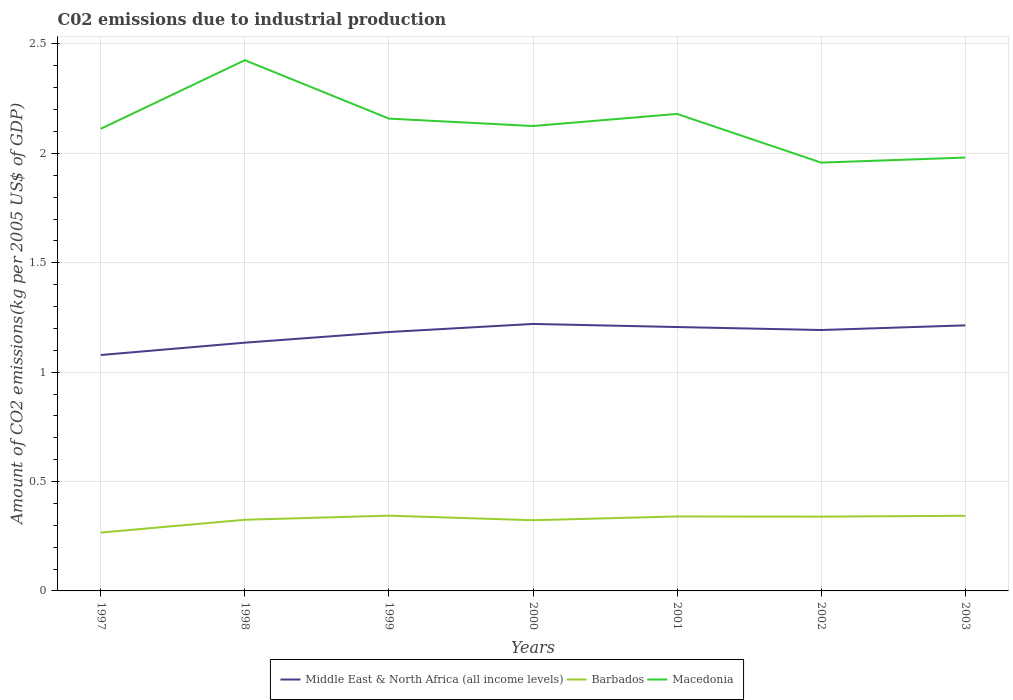How many different coloured lines are there?
Make the answer very short. 3. Does the line corresponding to Barbados intersect with the line corresponding to Macedonia?
Ensure brevity in your answer.  No. Across all years, what is the maximum amount of CO2 emitted due to industrial production in Macedonia?
Offer a terse response. 1.96. In which year was the amount of CO2 emitted due to industrial production in Middle East & North Africa (all income levels) maximum?
Give a very brief answer. 1997. What is the total amount of CO2 emitted due to industrial production in Barbados in the graph?
Make the answer very short. -0. What is the difference between the highest and the second highest amount of CO2 emitted due to industrial production in Middle East & North Africa (all income levels)?
Make the answer very short. 0.14. How many lines are there?
Give a very brief answer. 3. How many years are there in the graph?
Offer a very short reply. 7. Are the values on the major ticks of Y-axis written in scientific E-notation?
Ensure brevity in your answer.  No. Where does the legend appear in the graph?
Offer a very short reply. Bottom center. How many legend labels are there?
Make the answer very short. 3. How are the legend labels stacked?
Your response must be concise. Horizontal. What is the title of the graph?
Provide a short and direct response. C02 emissions due to industrial production. What is the label or title of the X-axis?
Make the answer very short. Years. What is the label or title of the Y-axis?
Make the answer very short. Amount of CO2 emissions(kg per 2005 US$ of GDP). What is the Amount of CO2 emissions(kg per 2005 US$ of GDP) in Middle East & North Africa (all income levels) in 1997?
Provide a succinct answer. 1.08. What is the Amount of CO2 emissions(kg per 2005 US$ of GDP) of Barbados in 1997?
Keep it short and to the point. 0.27. What is the Amount of CO2 emissions(kg per 2005 US$ of GDP) in Macedonia in 1997?
Make the answer very short. 2.11. What is the Amount of CO2 emissions(kg per 2005 US$ of GDP) in Middle East & North Africa (all income levels) in 1998?
Offer a terse response. 1.13. What is the Amount of CO2 emissions(kg per 2005 US$ of GDP) of Barbados in 1998?
Provide a short and direct response. 0.33. What is the Amount of CO2 emissions(kg per 2005 US$ of GDP) in Macedonia in 1998?
Provide a succinct answer. 2.43. What is the Amount of CO2 emissions(kg per 2005 US$ of GDP) of Middle East & North Africa (all income levels) in 1999?
Keep it short and to the point. 1.18. What is the Amount of CO2 emissions(kg per 2005 US$ of GDP) in Barbados in 1999?
Ensure brevity in your answer.  0.34. What is the Amount of CO2 emissions(kg per 2005 US$ of GDP) in Macedonia in 1999?
Your answer should be very brief. 2.16. What is the Amount of CO2 emissions(kg per 2005 US$ of GDP) in Middle East & North Africa (all income levels) in 2000?
Ensure brevity in your answer.  1.22. What is the Amount of CO2 emissions(kg per 2005 US$ of GDP) of Barbados in 2000?
Give a very brief answer. 0.32. What is the Amount of CO2 emissions(kg per 2005 US$ of GDP) of Macedonia in 2000?
Your answer should be compact. 2.13. What is the Amount of CO2 emissions(kg per 2005 US$ of GDP) of Middle East & North Africa (all income levels) in 2001?
Give a very brief answer. 1.21. What is the Amount of CO2 emissions(kg per 2005 US$ of GDP) in Barbados in 2001?
Give a very brief answer. 0.34. What is the Amount of CO2 emissions(kg per 2005 US$ of GDP) of Macedonia in 2001?
Your answer should be compact. 2.18. What is the Amount of CO2 emissions(kg per 2005 US$ of GDP) in Middle East & North Africa (all income levels) in 2002?
Provide a succinct answer. 1.19. What is the Amount of CO2 emissions(kg per 2005 US$ of GDP) of Barbados in 2002?
Give a very brief answer. 0.34. What is the Amount of CO2 emissions(kg per 2005 US$ of GDP) of Macedonia in 2002?
Your answer should be compact. 1.96. What is the Amount of CO2 emissions(kg per 2005 US$ of GDP) in Middle East & North Africa (all income levels) in 2003?
Provide a succinct answer. 1.21. What is the Amount of CO2 emissions(kg per 2005 US$ of GDP) of Barbados in 2003?
Make the answer very short. 0.34. What is the Amount of CO2 emissions(kg per 2005 US$ of GDP) of Macedonia in 2003?
Provide a short and direct response. 1.98. Across all years, what is the maximum Amount of CO2 emissions(kg per 2005 US$ of GDP) of Middle East & North Africa (all income levels)?
Provide a short and direct response. 1.22. Across all years, what is the maximum Amount of CO2 emissions(kg per 2005 US$ of GDP) in Barbados?
Your answer should be very brief. 0.34. Across all years, what is the maximum Amount of CO2 emissions(kg per 2005 US$ of GDP) of Macedonia?
Offer a very short reply. 2.43. Across all years, what is the minimum Amount of CO2 emissions(kg per 2005 US$ of GDP) of Middle East & North Africa (all income levels)?
Your answer should be compact. 1.08. Across all years, what is the minimum Amount of CO2 emissions(kg per 2005 US$ of GDP) of Barbados?
Ensure brevity in your answer.  0.27. Across all years, what is the minimum Amount of CO2 emissions(kg per 2005 US$ of GDP) of Macedonia?
Ensure brevity in your answer.  1.96. What is the total Amount of CO2 emissions(kg per 2005 US$ of GDP) in Middle East & North Africa (all income levels) in the graph?
Offer a very short reply. 8.23. What is the total Amount of CO2 emissions(kg per 2005 US$ of GDP) of Barbados in the graph?
Provide a short and direct response. 2.28. What is the total Amount of CO2 emissions(kg per 2005 US$ of GDP) in Macedonia in the graph?
Provide a succinct answer. 14.94. What is the difference between the Amount of CO2 emissions(kg per 2005 US$ of GDP) in Middle East & North Africa (all income levels) in 1997 and that in 1998?
Provide a succinct answer. -0.06. What is the difference between the Amount of CO2 emissions(kg per 2005 US$ of GDP) in Barbados in 1997 and that in 1998?
Offer a very short reply. -0.06. What is the difference between the Amount of CO2 emissions(kg per 2005 US$ of GDP) of Macedonia in 1997 and that in 1998?
Make the answer very short. -0.31. What is the difference between the Amount of CO2 emissions(kg per 2005 US$ of GDP) of Middle East & North Africa (all income levels) in 1997 and that in 1999?
Your response must be concise. -0.11. What is the difference between the Amount of CO2 emissions(kg per 2005 US$ of GDP) in Barbados in 1997 and that in 1999?
Provide a short and direct response. -0.08. What is the difference between the Amount of CO2 emissions(kg per 2005 US$ of GDP) of Macedonia in 1997 and that in 1999?
Offer a very short reply. -0.05. What is the difference between the Amount of CO2 emissions(kg per 2005 US$ of GDP) of Middle East & North Africa (all income levels) in 1997 and that in 2000?
Provide a succinct answer. -0.14. What is the difference between the Amount of CO2 emissions(kg per 2005 US$ of GDP) of Barbados in 1997 and that in 2000?
Your answer should be very brief. -0.06. What is the difference between the Amount of CO2 emissions(kg per 2005 US$ of GDP) in Macedonia in 1997 and that in 2000?
Your response must be concise. -0.01. What is the difference between the Amount of CO2 emissions(kg per 2005 US$ of GDP) in Middle East & North Africa (all income levels) in 1997 and that in 2001?
Provide a short and direct response. -0.13. What is the difference between the Amount of CO2 emissions(kg per 2005 US$ of GDP) of Barbados in 1997 and that in 2001?
Give a very brief answer. -0.07. What is the difference between the Amount of CO2 emissions(kg per 2005 US$ of GDP) of Macedonia in 1997 and that in 2001?
Your answer should be compact. -0.07. What is the difference between the Amount of CO2 emissions(kg per 2005 US$ of GDP) in Middle East & North Africa (all income levels) in 1997 and that in 2002?
Offer a very short reply. -0.11. What is the difference between the Amount of CO2 emissions(kg per 2005 US$ of GDP) in Barbados in 1997 and that in 2002?
Make the answer very short. -0.07. What is the difference between the Amount of CO2 emissions(kg per 2005 US$ of GDP) in Macedonia in 1997 and that in 2002?
Provide a short and direct response. 0.15. What is the difference between the Amount of CO2 emissions(kg per 2005 US$ of GDP) in Middle East & North Africa (all income levels) in 1997 and that in 2003?
Provide a succinct answer. -0.14. What is the difference between the Amount of CO2 emissions(kg per 2005 US$ of GDP) in Barbados in 1997 and that in 2003?
Give a very brief answer. -0.08. What is the difference between the Amount of CO2 emissions(kg per 2005 US$ of GDP) of Macedonia in 1997 and that in 2003?
Your answer should be very brief. 0.13. What is the difference between the Amount of CO2 emissions(kg per 2005 US$ of GDP) in Middle East & North Africa (all income levels) in 1998 and that in 1999?
Give a very brief answer. -0.05. What is the difference between the Amount of CO2 emissions(kg per 2005 US$ of GDP) of Barbados in 1998 and that in 1999?
Provide a short and direct response. -0.02. What is the difference between the Amount of CO2 emissions(kg per 2005 US$ of GDP) of Macedonia in 1998 and that in 1999?
Your response must be concise. 0.27. What is the difference between the Amount of CO2 emissions(kg per 2005 US$ of GDP) in Middle East & North Africa (all income levels) in 1998 and that in 2000?
Your response must be concise. -0.09. What is the difference between the Amount of CO2 emissions(kg per 2005 US$ of GDP) in Barbados in 1998 and that in 2000?
Offer a very short reply. 0. What is the difference between the Amount of CO2 emissions(kg per 2005 US$ of GDP) of Macedonia in 1998 and that in 2000?
Your answer should be very brief. 0.3. What is the difference between the Amount of CO2 emissions(kg per 2005 US$ of GDP) of Middle East & North Africa (all income levels) in 1998 and that in 2001?
Your answer should be very brief. -0.07. What is the difference between the Amount of CO2 emissions(kg per 2005 US$ of GDP) in Barbados in 1998 and that in 2001?
Provide a succinct answer. -0.02. What is the difference between the Amount of CO2 emissions(kg per 2005 US$ of GDP) of Macedonia in 1998 and that in 2001?
Your answer should be very brief. 0.25. What is the difference between the Amount of CO2 emissions(kg per 2005 US$ of GDP) in Middle East & North Africa (all income levels) in 1998 and that in 2002?
Keep it short and to the point. -0.06. What is the difference between the Amount of CO2 emissions(kg per 2005 US$ of GDP) in Barbados in 1998 and that in 2002?
Your answer should be compact. -0.01. What is the difference between the Amount of CO2 emissions(kg per 2005 US$ of GDP) of Macedonia in 1998 and that in 2002?
Your response must be concise. 0.47. What is the difference between the Amount of CO2 emissions(kg per 2005 US$ of GDP) of Middle East & North Africa (all income levels) in 1998 and that in 2003?
Keep it short and to the point. -0.08. What is the difference between the Amount of CO2 emissions(kg per 2005 US$ of GDP) in Barbados in 1998 and that in 2003?
Provide a succinct answer. -0.02. What is the difference between the Amount of CO2 emissions(kg per 2005 US$ of GDP) in Macedonia in 1998 and that in 2003?
Ensure brevity in your answer.  0.45. What is the difference between the Amount of CO2 emissions(kg per 2005 US$ of GDP) of Middle East & North Africa (all income levels) in 1999 and that in 2000?
Make the answer very short. -0.04. What is the difference between the Amount of CO2 emissions(kg per 2005 US$ of GDP) in Barbados in 1999 and that in 2000?
Keep it short and to the point. 0.02. What is the difference between the Amount of CO2 emissions(kg per 2005 US$ of GDP) of Macedonia in 1999 and that in 2000?
Give a very brief answer. 0.03. What is the difference between the Amount of CO2 emissions(kg per 2005 US$ of GDP) of Middle East & North Africa (all income levels) in 1999 and that in 2001?
Ensure brevity in your answer.  -0.02. What is the difference between the Amount of CO2 emissions(kg per 2005 US$ of GDP) of Barbados in 1999 and that in 2001?
Keep it short and to the point. 0. What is the difference between the Amount of CO2 emissions(kg per 2005 US$ of GDP) in Macedonia in 1999 and that in 2001?
Give a very brief answer. -0.02. What is the difference between the Amount of CO2 emissions(kg per 2005 US$ of GDP) of Middle East & North Africa (all income levels) in 1999 and that in 2002?
Your response must be concise. -0.01. What is the difference between the Amount of CO2 emissions(kg per 2005 US$ of GDP) of Barbados in 1999 and that in 2002?
Make the answer very short. 0. What is the difference between the Amount of CO2 emissions(kg per 2005 US$ of GDP) of Macedonia in 1999 and that in 2002?
Make the answer very short. 0.2. What is the difference between the Amount of CO2 emissions(kg per 2005 US$ of GDP) of Middle East & North Africa (all income levels) in 1999 and that in 2003?
Offer a very short reply. -0.03. What is the difference between the Amount of CO2 emissions(kg per 2005 US$ of GDP) in Barbados in 1999 and that in 2003?
Your answer should be compact. 0. What is the difference between the Amount of CO2 emissions(kg per 2005 US$ of GDP) of Macedonia in 1999 and that in 2003?
Keep it short and to the point. 0.18. What is the difference between the Amount of CO2 emissions(kg per 2005 US$ of GDP) of Middle East & North Africa (all income levels) in 2000 and that in 2001?
Provide a succinct answer. 0.01. What is the difference between the Amount of CO2 emissions(kg per 2005 US$ of GDP) of Barbados in 2000 and that in 2001?
Provide a short and direct response. -0.02. What is the difference between the Amount of CO2 emissions(kg per 2005 US$ of GDP) in Macedonia in 2000 and that in 2001?
Offer a very short reply. -0.06. What is the difference between the Amount of CO2 emissions(kg per 2005 US$ of GDP) of Middle East & North Africa (all income levels) in 2000 and that in 2002?
Offer a terse response. 0.03. What is the difference between the Amount of CO2 emissions(kg per 2005 US$ of GDP) in Barbados in 2000 and that in 2002?
Give a very brief answer. -0.02. What is the difference between the Amount of CO2 emissions(kg per 2005 US$ of GDP) of Macedonia in 2000 and that in 2002?
Offer a very short reply. 0.17. What is the difference between the Amount of CO2 emissions(kg per 2005 US$ of GDP) of Middle East & North Africa (all income levels) in 2000 and that in 2003?
Offer a terse response. 0.01. What is the difference between the Amount of CO2 emissions(kg per 2005 US$ of GDP) of Barbados in 2000 and that in 2003?
Ensure brevity in your answer.  -0.02. What is the difference between the Amount of CO2 emissions(kg per 2005 US$ of GDP) in Macedonia in 2000 and that in 2003?
Your answer should be very brief. 0.14. What is the difference between the Amount of CO2 emissions(kg per 2005 US$ of GDP) of Middle East & North Africa (all income levels) in 2001 and that in 2002?
Keep it short and to the point. 0.01. What is the difference between the Amount of CO2 emissions(kg per 2005 US$ of GDP) of Barbados in 2001 and that in 2002?
Make the answer very short. 0. What is the difference between the Amount of CO2 emissions(kg per 2005 US$ of GDP) in Macedonia in 2001 and that in 2002?
Provide a short and direct response. 0.22. What is the difference between the Amount of CO2 emissions(kg per 2005 US$ of GDP) in Middle East & North Africa (all income levels) in 2001 and that in 2003?
Your response must be concise. -0.01. What is the difference between the Amount of CO2 emissions(kg per 2005 US$ of GDP) in Barbados in 2001 and that in 2003?
Provide a short and direct response. -0. What is the difference between the Amount of CO2 emissions(kg per 2005 US$ of GDP) in Macedonia in 2001 and that in 2003?
Ensure brevity in your answer.  0.2. What is the difference between the Amount of CO2 emissions(kg per 2005 US$ of GDP) in Middle East & North Africa (all income levels) in 2002 and that in 2003?
Provide a succinct answer. -0.02. What is the difference between the Amount of CO2 emissions(kg per 2005 US$ of GDP) of Barbados in 2002 and that in 2003?
Your answer should be very brief. -0. What is the difference between the Amount of CO2 emissions(kg per 2005 US$ of GDP) of Macedonia in 2002 and that in 2003?
Your answer should be compact. -0.02. What is the difference between the Amount of CO2 emissions(kg per 2005 US$ of GDP) in Middle East & North Africa (all income levels) in 1997 and the Amount of CO2 emissions(kg per 2005 US$ of GDP) in Barbados in 1998?
Give a very brief answer. 0.75. What is the difference between the Amount of CO2 emissions(kg per 2005 US$ of GDP) of Middle East & North Africa (all income levels) in 1997 and the Amount of CO2 emissions(kg per 2005 US$ of GDP) of Macedonia in 1998?
Offer a very short reply. -1.35. What is the difference between the Amount of CO2 emissions(kg per 2005 US$ of GDP) of Barbados in 1997 and the Amount of CO2 emissions(kg per 2005 US$ of GDP) of Macedonia in 1998?
Provide a short and direct response. -2.16. What is the difference between the Amount of CO2 emissions(kg per 2005 US$ of GDP) of Middle East & North Africa (all income levels) in 1997 and the Amount of CO2 emissions(kg per 2005 US$ of GDP) of Barbados in 1999?
Ensure brevity in your answer.  0.73. What is the difference between the Amount of CO2 emissions(kg per 2005 US$ of GDP) in Middle East & North Africa (all income levels) in 1997 and the Amount of CO2 emissions(kg per 2005 US$ of GDP) in Macedonia in 1999?
Your answer should be very brief. -1.08. What is the difference between the Amount of CO2 emissions(kg per 2005 US$ of GDP) of Barbados in 1997 and the Amount of CO2 emissions(kg per 2005 US$ of GDP) of Macedonia in 1999?
Your answer should be compact. -1.89. What is the difference between the Amount of CO2 emissions(kg per 2005 US$ of GDP) in Middle East & North Africa (all income levels) in 1997 and the Amount of CO2 emissions(kg per 2005 US$ of GDP) in Barbados in 2000?
Your response must be concise. 0.76. What is the difference between the Amount of CO2 emissions(kg per 2005 US$ of GDP) of Middle East & North Africa (all income levels) in 1997 and the Amount of CO2 emissions(kg per 2005 US$ of GDP) of Macedonia in 2000?
Offer a very short reply. -1.05. What is the difference between the Amount of CO2 emissions(kg per 2005 US$ of GDP) of Barbados in 1997 and the Amount of CO2 emissions(kg per 2005 US$ of GDP) of Macedonia in 2000?
Make the answer very short. -1.86. What is the difference between the Amount of CO2 emissions(kg per 2005 US$ of GDP) in Middle East & North Africa (all income levels) in 1997 and the Amount of CO2 emissions(kg per 2005 US$ of GDP) in Barbados in 2001?
Your answer should be very brief. 0.74. What is the difference between the Amount of CO2 emissions(kg per 2005 US$ of GDP) of Middle East & North Africa (all income levels) in 1997 and the Amount of CO2 emissions(kg per 2005 US$ of GDP) of Macedonia in 2001?
Offer a very short reply. -1.1. What is the difference between the Amount of CO2 emissions(kg per 2005 US$ of GDP) of Barbados in 1997 and the Amount of CO2 emissions(kg per 2005 US$ of GDP) of Macedonia in 2001?
Your response must be concise. -1.91. What is the difference between the Amount of CO2 emissions(kg per 2005 US$ of GDP) in Middle East & North Africa (all income levels) in 1997 and the Amount of CO2 emissions(kg per 2005 US$ of GDP) in Barbados in 2002?
Your response must be concise. 0.74. What is the difference between the Amount of CO2 emissions(kg per 2005 US$ of GDP) in Middle East & North Africa (all income levels) in 1997 and the Amount of CO2 emissions(kg per 2005 US$ of GDP) in Macedonia in 2002?
Your answer should be compact. -0.88. What is the difference between the Amount of CO2 emissions(kg per 2005 US$ of GDP) in Barbados in 1997 and the Amount of CO2 emissions(kg per 2005 US$ of GDP) in Macedonia in 2002?
Provide a short and direct response. -1.69. What is the difference between the Amount of CO2 emissions(kg per 2005 US$ of GDP) of Middle East & North Africa (all income levels) in 1997 and the Amount of CO2 emissions(kg per 2005 US$ of GDP) of Barbados in 2003?
Keep it short and to the point. 0.73. What is the difference between the Amount of CO2 emissions(kg per 2005 US$ of GDP) in Middle East & North Africa (all income levels) in 1997 and the Amount of CO2 emissions(kg per 2005 US$ of GDP) in Macedonia in 2003?
Ensure brevity in your answer.  -0.9. What is the difference between the Amount of CO2 emissions(kg per 2005 US$ of GDP) of Barbados in 1997 and the Amount of CO2 emissions(kg per 2005 US$ of GDP) of Macedonia in 2003?
Your answer should be very brief. -1.71. What is the difference between the Amount of CO2 emissions(kg per 2005 US$ of GDP) of Middle East & North Africa (all income levels) in 1998 and the Amount of CO2 emissions(kg per 2005 US$ of GDP) of Barbados in 1999?
Offer a terse response. 0.79. What is the difference between the Amount of CO2 emissions(kg per 2005 US$ of GDP) of Middle East & North Africa (all income levels) in 1998 and the Amount of CO2 emissions(kg per 2005 US$ of GDP) of Macedonia in 1999?
Offer a terse response. -1.02. What is the difference between the Amount of CO2 emissions(kg per 2005 US$ of GDP) of Barbados in 1998 and the Amount of CO2 emissions(kg per 2005 US$ of GDP) of Macedonia in 1999?
Provide a succinct answer. -1.83. What is the difference between the Amount of CO2 emissions(kg per 2005 US$ of GDP) of Middle East & North Africa (all income levels) in 1998 and the Amount of CO2 emissions(kg per 2005 US$ of GDP) of Barbados in 2000?
Offer a very short reply. 0.81. What is the difference between the Amount of CO2 emissions(kg per 2005 US$ of GDP) of Middle East & North Africa (all income levels) in 1998 and the Amount of CO2 emissions(kg per 2005 US$ of GDP) of Macedonia in 2000?
Make the answer very short. -0.99. What is the difference between the Amount of CO2 emissions(kg per 2005 US$ of GDP) in Barbados in 1998 and the Amount of CO2 emissions(kg per 2005 US$ of GDP) in Macedonia in 2000?
Your response must be concise. -1.8. What is the difference between the Amount of CO2 emissions(kg per 2005 US$ of GDP) of Middle East & North Africa (all income levels) in 1998 and the Amount of CO2 emissions(kg per 2005 US$ of GDP) of Barbados in 2001?
Your answer should be compact. 0.79. What is the difference between the Amount of CO2 emissions(kg per 2005 US$ of GDP) of Middle East & North Africa (all income levels) in 1998 and the Amount of CO2 emissions(kg per 2005 US$ of GDP) of Macedonia in 2001?
Provide a short and direct response. -1.05. What is the difference between the Amount of CO2 emissions(kg per 2005 US$ of GDP) in Barbados in 1998 and the Amount of CO2 emissions(kg per 2005 US$ of GDP) in Macedonia in 2001?
Provide a short and direct response. -1.86. What is the difference between the Amount of CO2 emissions(kg per 2005 US$ of GDP) in Middle East & North Africa (all income levels) in 1998 and the Amount of CO2 emissions(kg per 2005 US$ of GDP) in Barbados in 2002?
Make the answer very short. 0.8. What is the difference between the Amount of CO2 emissions(kg per 2005 US$ of GDP) in Middle East & North Africa (all income levels) in 1998 and the Amount of CO2 emissions(kg per 2005 US$ of GDP) in Macedonia in 2002?
Provide a succinct answer. -0.82. What is the difference between the Amount of CO2 emissions(kg per 2005 US$ of GDP) in Barbados in 1998 and the Amount of CO2 emissions(kg per 2005 US$ of GDP) in Macedonia in 2002?
Give a very brief answer. -1.63. What is the difference between the Amount of CO2 emissions(kg per 2005 US$ of GDP) in Middle East & North Africa (all income levels) in 1998 and the Amount of CO2 emissions(kg per 2005 US$ of GDP) in Barbados in 2003?
Provide a short and direct response. 0.79. What is the difference between the Amount of CO2 emissions(kg per 2005 US$ of GDP) of Middle East & North Africa (all income levels) in 1998 and the Amount of CO2 emissions(kg per 2005 US$ of GDP) of Macedonia in 2003?
Offer a terse response. -0.85. What is the difference between the Amount of CO2 emissions(kg per 2005 US$ of GDP) of Barbados in 1998 and the Amount of CO2 emissions(kg per 2005 US$ of GDP) of Macedonia in 2003?
Offer a very short reply. -1.66. What is the difference between the Amount of CO2 emissions(kg per 2005 US$ of GDP) in Middle East & North Africa (all income levels) in 1999 and the Amount of CO2 emissions(kg per 2005 US$ of GDP) in Barbados in 2000?
Offer a terse response. 0.86. What is the difference between the Amount of CO2 emissions(kg per 2005 US$ of GDP) of Middle East & North Africa (all income levels) in 1999 and the Amount of CO2 emissions(kg per 2005 US$ of GDP) of Macedonia in 2000?
Your response must be concise. -0.94. What is the difference between the Amount of CO2 emissions(kg per 2005 US$ of GDP) in Barbados in 1999 and the Amount of CO2 emissions(kg per 2005 US$ of GDP) in Macedonia in 2000?
Offer a very short reply. -1.78. What is the difference between the Amount of CO2 emissions(kg per 2005 US$ of GDP) of Middle East & North Africa (all income levels) in 1999 and the Amount of CO2 emissions(kg per 2005 US$ of GDP) of Barbados in 2001?
Provide a short and direct response. 0.84. What is the difference between the Amount of CO2 emissions(kg per 2005 US$ of GDP) in Middle East & North Africa (all income levels) in 1999 and the Amount of CO2 emissions(kg per 2005 US$ of GDP) in Macedonia in 2001?
Offer a very short reply. -1. What is the difference between the Amount of CO2 emissions(kg per 2005 US$ of GDP) of Barbados in 1999 and the Amount of CO2 emissions(kg per 2005 US$ of GDP) of Macedonia in 2001?
Make the answer very short. -1.84. What is the difference between the Amount of CO2 emissions(kg per 2005 US$ of GDP) of Middle East & North Africa (all income levels) in 1999 and the Amount of CO2 emissions(kg per 2005 US$ of GDP) of Barbados in 2002?
Provide a succinct answer. 0.84. What is the difference between the Amount of CO2 emissions(kg per 2005 US$ of GDP) of Middle East & North Africa (all income levels) in 1999 and the Amount of CO2 emissions(kg per 2005 US$ of GDP) of Macedonia in 2002?
Offer a terse response. -0.77. What is the difference between the Amount of CO2 emissions(kg per 2005 US$ of GDP) of Barbados in 1999 and the Amount of CO2 emissions(kg per 2005 US$ of GDP) of Macedonia in 2002?
Offer a very short reply. -1.61. What is the difference between the Amount of CO2 emissions(kg per 2005 US$ of GDP) of Middle East & North Africa (all income levels) in 1999 and the Amount of CO2 emissions(kg per 2005 US$ of GDP) of Barbados in 2003?
Provide a succinct answer. 0.84. What is the difference between the Amount of CO2 emissions(kg per 2005 US$ of GDP) of Middle East & North Africa (all income levels) in 1999 and the Amount of CO2 emissions(kg per 2005 US$ of GDP) of Macedonia in 2003?
Offer a very short reply. -0.8. What is the difference between the Amount of CO2 emissions(kg per 2005 US$ of GDP) of Barbados in 1999 and the Amount of CO2 emissions(kg per 2005 US$ of GDP) of Macedonia in 2003?
Provide a short and direct response. -1.64. What is the difference between the Amount of CO2 emissions(kg per 2005 US$ of GDP) of Middle East & North Africa (all income levels) in 2000 and the Amount of CO2 emissions(kg per 2005 US$ of GDP) of Barbados in 2001?
Keep it short and to the point. 0.88. What is the difference between the Amount of CO2 emissions(kg per 2005 US$ of GDP) in Middle East & North Africa (all income levels) in 2000 and the Amount of CO2 emissions(kg per 2005 US$ of GDP) in Macedonia in 2001?
Give a very brief answer. -0.96. What is the difference between the Amount of CO2 emissions(kg per 2005 US$ of GDP) of Barbados in 2000 and the Amount of CO2 emissions(kg per 2005 US$ of GDP) of Macedonia in 2001?
Give a very brief answer. -1.86. What is the difference between the Amount of CO2 emissions(kg per 2005 US$ of GDP) in Middle East & North Africa (all income levels) in 2000 and the Amount of CO2 emissions(kg per 2005 US$ of GDP) in Barbados in 2002?
Offer a very short reply. 0.88. What is the difference between the Amount of CO2 emissions(kg per 2005 US$ of GDP) of Middle East & North Africa (all income levels) in 2000 and the Amount of CO2 emissions(kg per 2005 US$ of GDP) of Macedonia in 2002?
Give a very brief answer. -0.74. What is the difference between the Amount of CO2 emissions(kg per 2005 US$ of GDP) of Barbados in 2000 and the Amount of CO2 emissions(kg per 2005 US$ of GDP) of Macedonia in 2002?
Keep it short and to the point. -1.63. What is the difference between the Amount of CO2 emissions(kg per 2005 US$ of GDP) of Middle East & North Africa (all income levels) in 2000 and the Amount of CO2 emissions(kg per 2005 US$ of GDP) of Barbados in 2003?
Make the answer very short. 0.88. What is the difference between the Amount of CO2 emissions(kg per 2005 US$ of GDP) of Middle East & North Africa (all income levels) in 2000 and the Amount of CO2 emissions(kg per 2005 US$ of GDP) of Macedonia in 2003?
Your response must be concise. -0.76. What is the difference between the Amount of CO2 emissions(kg per 2005 US$ of GDP) of Barbados in 2000 and the Amount of CO2 emissions(kg per 2005 US$ of GDP) of Macedonia in 2003?
Your answer should be very brief. -1.66. What is the difference between the Amount of CO2 emissions(kg per 2005 US$ of GDP) of Middle East & North Africa (all income levels) in 2001 and the Amount of CO2 emissions(kg per 2005 US$ of GDP) of Barbados in 2002?
Provide a short and direct response. 0.87. What is the difference between the Amount of CO2 emissions(kg per 2005 US$ of GDP) of Middle East & North Africa (all income levels) in 2001 and the Amount of CO2 emissions(kg per 2005 US$ of GDP) of Macedonia in 2002?
Your response must be concise. -0.75. What is the difference between the Amount of CO2 emissions(kg per 2005 US$ of GDP) of Barbados in 2001 and the Amount of CO2 emissions(kg per 2005 US$ of GDP) of Macedonia in 2002?
Provide a short and direct response. -1.62. What is the difference between the Amount of CO2 emissions(kg per 2005 US$ of GDP) in Middle East & North Africa (all income levels) in 2001 and the Amount of CO2 emissions(kg per 2005 US$ of GDP) in Barbados in 2003?
Give a very brief answer. 0.86. What is the difference between the Amount of CO2 emissions(kg per 2005 US$ of GDP) of Middle East & North Africa (all income levels) in 2001 and the Amount of CO2 emissions(kg per 2005 US$ of GDP) of Macedonia in 2003?
Make the answer very short. -0.77. What is the difference between the Amount of CO2 emissions(kg per 2005 US$ of GDP) of Barbados in 2001 and the Amount of CO2 emissions(kg per 2005 US$ of GDP) of Macedonia in 2003?
Your answer should be very brief. -1.64. What is the difference between the Amount of CO2 emissions(kg per 2005 US$ of GDP) of Middle East & North Africa (all income levels) in 2002 and the Amount of CO2 emissions(kg per 2005 US$ of GDP) of Barbados in 2003?
Give a very brief answer. 0.85. What is the difference between the Amount of CO2 emissions(kg per 2005 US$ of GDP) of Middle East & North Africa (all income levels) in 2002 and the Amount of CO2 emissions(kg per 2005 US$ of GDP) of Macedonia in 2003?
Give a very brief answer. -0.79. What is the difference between the Amount of CO2 emissions(kg per 2005 US$ of GDP) of Barbados in 2002 and the Amount of CO2 emissions(kg per 2005 US$ of GDP) of Macedonia in 2003?
Give a very brief answer. -1.64. What is the average Amount of CO2 emissions(kg per 2005 US$ of GDP) in Middle East & North Africa (all income levels) per year?
Keep it short and to the point. 1.18. What is the average Amount of CO2 emissions(kg per 2005 US$ of GDP) of Barbados per year?
Your response must be concise. 0.33. What is the average Amount of CO2 emissions(kg per 2005 US$ of GDP) of Macedonia per year?
Your response must be concise. 2.13. In the year 1997, what is the difference between the Amount of CO2 emissions(kg per 2005 US$ of GDP) of Middle East & North Africa (all income levels) and Amount of CO2 emissions(kg per 2005 US$ of GDP) of Barbados?
Keep it short and to the point. 0.81. In the year 1997, what is the difference between the Amount of CO2 emissions(kg per 2005 US$ of GDP) in Middle East & North Africa (all income levels) and Amount of CO2 emissions(kg per 2005 US$ of GDP) in Macedonia?
Your answer should be very brief. -1.03. In the year 1997, what is the difference between the Amount of CO2 emissions(kg per 2005 US$ of GDP) in Barbados and Amount of CO2 emissions(kg per 2005 US$ of GDP) in Macedonia?
Offer a very short reply. -1.85. In the year 1998, what is the difference between the Amount of CO2 emissions(kg per 2005 US$ of GDP) in Middle East & North Africa (all income levels) and Amount of CO2 emissions(kg per 2005 US$ of GDP) in Barbados?
Offer a terse response. 0.81. In the year 1998, what is the difference between the Amount of CO2 emissions(kg per 2005 US$ of GDP) of Middle East & North Africa (all income levels) and Amount of CO2 emissions(kg per 2005 US$ of GDP) of Macedonia?
Provide a short and direct response. -1.29. In the year 1998, what is the difference between the Amount of CO2 emissions(kg per 2005 US$ of GDP) of Barbados and Amount of CO2 emissions(kg per 2005 US$ of GDP) of Macedonia?
Your answer should be compact. -2.1. In the year 1999, what is the difference between the Amount of CO2 emissions(kg per 2005 US$ of GDP) in Middle East & North Africa (all income levels) and Amount of CO2 emissions(kg per 2005 US$ of GDP) in Barbados?
Ensure brevity in your answer.  0.84. In the year 1999, what is the difference between the Amount of CO2 emissions(kg per 2005 US$ of GDP) of Middle East & North Africa (all income levels) and Amount of CO2 emissions(kg per 2005 US$ of GDP) of Macedonia?
Provide a succinct answer. -0.98. In the year 1999, what is the difference between the Amount of CO2 emissions(kg per 2005 US$ of GDP) in Barbados and Amount of CO2 emissions(kg per 2005 US$ of GDP) in Macedonia?
Provide a succinct answer. -1.81. In the year 2000, what is the difference between the Amount of CO2 emissions(kg per 2005 US$ of GDP) in Middle East & North Africa (all income levels) and Amount of CO2 emissions(kg per 2005 US$ of GDP) in Barbados?
Offer a terse response. 0.9. In the year 2000, what is the difference between the Amount of CO2 emissions(kg per 2005 US$ of GDP) of Middle East & North Africa (all income levels) and Amount of CO2 emissions(kg per 2005 US$ of GDP) of Macedonia?
Offer a very short reply. -0.9. In the year 2000, what is the difference between the Amount of CO2 emissions(kg per 2005 US$ of GDP) of Barbados and Amount of CO2 emissions(kg per 2005 US$ of GDP) of Macedonia?
Give a very brief answer. -1.8. In the year 2001, what is the difference between the Amount of CO2 emissions(kg per 2005 US$ of GDP) in Middle East & North Africa (all income levels) and Amount of CO2 emissions(kg per 2005 US$ of GDP) in Barbados?
Provide a succinct answer. 0.87. In the year 2001, what is the difference between the Amount of CO2 emissions(kg per 2005 US$ of GDP) of Middle East & North Africa (all income levels) and Amount of CO2 emissions(kg per 2005 US$ of GDP) of Macedonia?
Your answer should be very brief. -0.97. In the year 2001, what is the difference between the Amount of CO2 emissions(kg per 2005 US$ of GDP) in Barbados and Amount of CO2 emissions(kg per 2005 US$ of GDP) in Macedonia?
Your answer should be very brief. -1.84. In the year 2002, what is the difference between the Amount of CO2 emissions(kg per 2005 US$ of GDP) in Middle East & North Africa (all income levels) and Amount of CO2 emissions(kg per 2005 US$ of GDP) in Barbados?
Your response must be concise. 0.85. In the year 2002, what is the difference between the Amount of CO2 emissions(kg per 2005 US$ of GDP) of Middle East & North Africa (all income levels) and Amount of CO2 emissions(kg per 2005 US$ of GDP) of Macedonia?
Offer a terse response. -0.77. In the year 2002, what is the difference between the Amount of CO2 emissions(kg per 2005 US$ of GDP) in Barbados and Amount of CO2 emissions(kg per 2005 US$ of GDP) in Macedonia?
Your answer should be compact. -1.62. In the year 2003, what is the difference between the Amount of CO2 emissions(kg per 2005 US$ of GDP) of Middle East & North Africa (all income levels) and Amount of CO2 emissions(kg per 2005 US$ of GDP) of Barbados?
Offer a terse response. 0.87. In the year 2003, what is the difference between the Amount of CO2 emissions(kg per 2005 US$ of GDP) in Middle East & North Africa (all income levels) and Amount of CO2 emissions(kg per 2005 US$ of GDP) in Macedonia?
Give a very brief answer. -0.77. In the year 2003, what is the difference between the Amount of CO2 emissions(kg per 2005 US$ of GDP) of Barbados and Amount of CO2 emissions(kg per 2005 US$ of GDP) of Macedonia?
Give a very brief answer. -1.64. What is the ratio of the Amount of CO2 emissions(kg per 2005 US$ of GDP) in Middle East & North Africa (all income levels) in 1997 to that in 1998?
Provide a succinct answer. 0.95. What is the ratio of the Amount of CO2 emissions(kg per 2005 US$ of GDP) in Barbados in 1997 to that in 1998?
Ensure brevity in your answer.  0.82. What is the ratio of the Amount of CO2 emissions(kg per 2005 US$ of GDP) of Macedonia in 1997 to that in 1998?
Offer a very short reply. 0.87. What is the ratio of the Amount of CO2 emissions(kg per 2005 US$ of GDP) in Middle East & North Africa (all income levels) in 1997 to that in 1999?
Ensure brevity in your answer.  0.91. What is the ratio of the Amount of CO2 emissions(kg per 2005 US$ of GDP) in Barbados in 1997 to that in 1999?
Offer a very short reply. 0.78. What is the ratio of the Amount of CO2 emissions(kg per 2005 US$ of GDP) in Macedonia in 1997 to that in 1999?
Offer a very short reply. 0.98. What is the ratio of the Amount of CO2 emissions(kg per 2005 US$ of GDP) of Middle East & North Africa (all income levels) in 1997 to that in 2000?
Provide a succinct answer. 0.88. What is the ratio of the Amount of CO2 emissions(kg per 2005 US$ of GDP) in Barbados in 1997 to that in 2000?
Your answer should be very brief. 0.83. What is the ratio of the Amount of CO2 emissions(kg per 2005 US$ of GDP) of Middle East & North Africa (all income levels) in 1997 to that in 2001?
Make the answer very short. 0.89. What is the ratio of the Amount of CO2 emissions(kg per 2005 US$ of GDP) of Barbados in 1997 to that in 2001?
Provide a succinct answer. 0.78. What is the ratio of the Amount of CO2 emissions(kg per 2005 US$ of GDP) in Macedonia in 1997 to that in 2001?
Offer a terse response. 0.97. What is the ratio of the Amount of CO2 emissions(kg per 2005 US$ of GDP) of Middle East & North Africa (all income levels) in 1997 to that in 2002?
Offer a terse response. 0.9. What is the ratio of the Amount of CO2 emissions(kg per 2005 US$ of GDP) in Barbados in 1997 to that in 2002?
Give a very brief answer. 0.79. What is the ratio of the Amount of CO2 emissions(kg per 2005 US$ of GDP) of Macedonia in 1997 to that in 2002?
Offer a terse response. 1.08. What is the ratio of the Amount of CO2 emissions(kg per 2005 US$ of GDP) of Middle East & North Africa (all income levels) in 1997 to that in 2003?
Make the answer very short. 0.89. What is the ratio of the Amount of CO2 emissions(kg per 2005 US$ of GDP) of Barbados in 1997 to that in 2003?
Provide a short and direct response. 0.78. What is the ratio of the Amount of CO2 emissions(kg per 2005 US$ of GDP) in Macedonia in 1997 to that in 2003?
Offer a very short reply. 1.07. What is the ratio of the Amount of CO2 emissions(kg per 2005 US$ of GDP) in Middle East & North Africa (all income levels) in 1998 to that in 1999?
Make the answer very short. 0.96. What is the ratio of the Amount of CO2 emissions(kg per 2005 US$ of GDP) of Barbados in 1998 to that in 1999?
Offer a very short reply. 0.95. What is the ratio of the Amount of CO2 emissions(kg per 2005 US$ of GDP) of Macedonia in 1998 to that in 1999?
Make the answer very short. 1.12. What is the ratio of the Amount of CO2 emissions(kg per 2005 US$ of GDP) of Middle East & North Africa (all income levels) in 1998 to that in 2000?
Keep it short and to the point. 0.93. What is the ratio of the Amount of CO2 emissions(kg per 2005 US$ of GDP) in Barbados in 1998 to that in 2000?
Ensure brevity in your answer.  1.01. What is the ratio of the Amount of CO2 emissions(kg per 2005 US$ of GDP) of Macedonia in 1998 to that in 2000?
Your answer should be compact. 1.14. What is the ratio of the Amount of CO2 emissions(kg per 2005 US$ of GDP) in Middle East & North Africa (all income levels) in 1998 to that in 2001?
Your response must be concise. 0.94. What is the ratio of the Amount of CO2 emissions(kg per 2005 US$ of GDP) of Barbados in 1998 to that in 2001?
Offer a terse response. 0.96. What is the ratio of the Amount of CO2 emissions(kg per 2005 US$ of GDP) in Macedonia in 1998 to that in 2001?
Your answer should be very brief. 1.11. What is the ratio of the Amount of CO2 emissions(kg per 2005 US$ of GDP) in Middle East & North Africa (all income levels) in 1998 to that in 2002?
Provide a succinct answer. 0.95. What is the ratio of the Amount of CO2 emissions(kg per 2005 US$ of GDP) in Barbados in 1998 to that in 2002?
Offer a terse response. 0.96. What is the ratio of the Amount of CO2 emissions(kg per 2005 US$ of GDP) of Macedonia in 1998 to that in 2002?
Your answer should be compact. 1.24. What is the ratio of the Amount of CO2 emissions(kg per 2005 US$ of GDP) in Middle East & North Africa (all income levels) in 1998 to that in 2003?
Offer a terse response. 0.93. What is the ratio of the Amount of CO2 emissions(kg per 2005 US$ of GDP) in Barbados in 1998 to that in 2003?
Offer a terse response. 0.95. What is the ratio of the Amount of CO2 emissions(kg per 2005 US$ of GDP) of Macedonia in 1998 to that in 2003?
Keep it short and to the point. 1.22. What is the ratio of the Amount of CO2 emissions(kg per 2005 US$ of GDP) of Middle East & North Africa (all income levels) in 1999 to that in 2000?
Provide a short and direct response. 0.97. What is the ratio of the Amount of CO2 emissions(kg per 2005 US$ of GDP) in Barbados in 1999 to that in 2000?
Provide a short and direct response. 1.06. What is the ratio of the Amount of CO2 emissions(kg per 2005 US$ of GDP) in Macedonia in 1999 to that in 2000?
Offer a very short reply. 1.02. What is the ratio of the Amount of CO2 emissions(kg per 2005 US$ of GDP) of Middle East & North Africa (all income levels) in 1999 to that in 2001?
Your answer should be compact. 0.98. What is the ratio of the Amount of CO2 emissions(kg per 2005 US$ of GDP) in Barbados in 1999 to that in 2001?
Give a very brief answer. 1.01. What is the ratio of the Amount of CO2 emissions(kg per 2005 US$ of GDP) in Macedonia in 1999 to that in 2001?
Give a very brief answer. 0.99. What is the ratio of the Amount of CO2 emissions(kg per 2005 US$ of GDP) in Middle East & North Africa (all income levels) in 1999 to that in 2002?
Make the answer very short. 0.99. What is the ratio of the Amount of CO2 emissions(kg per 2005 US$ of GDP) of Macedonia in 1999 to that in 2002?
Your answer should be compact. 1.1. What is the ratio of the Amount of CO2 emissions(kg per 2005 US$ of GDP) of Middle East & North Africa (all income levels) in 1999 to that in 2003?
Make the answer very short. 0.97. What is the ratio of the Amount of CO2 emissions(kg per 2005 US$ of GDP) of Macedonia in 1999 to that in 2003?
Offer a terse response. 1.09. What is the ratio of the Amount of CO2 emissions(kg per 2005 US$ of GDP) in Middle East & North Africa (all income levels) in 2000 to that in 2001?
Offer a terse response. 1.01. What is the ratio of the Amount of CO2 emissions(kg per 2005 US$ of GDP) in Barbados in 2000 to that in 2001?
Give a very brief answer. 0.95. What is the ratio of the Amount of CO2 emissions(kg per 2005 US$ of GDP) in Macedonia in 2000 to that in 2001?
Your response must be concise. 0.97. What is the ratio of the Amount of CO2 emissions(kg per 2005 US$ of GDP) in Middle East & North Africa (all income levels) in 2000 to that in 2002?
Your response must be concise. 1.02. What is the ratio of the Amount of CO2 emissions(kg per 2005 US$ of GDP) of Barbados in 2000 to that in 2002?
Your answer should be compact. 0.95. What is the ratio of the Amount of CO2 emissions(kg per 2005 US$ of GDP) in Macedonia in 2000 to that in 2002?
Your response must be concise. 1.09. What is the ratio of the Amount of CO2 emissions(kg per 2005 US$ of GDP) of Middle East & North Africa (all income levels) in 2000 to that in 2003?
Keep it short and to the point. 1.01. What is the ratio of the Amount of CO2 emissions(kg per 2005 US$ of GDP) in Barbados in 2000 to that in 2003?
Your answer should be very brief. 0.94. What is the ratio of the Amount of CO2 emissions(kg per 2005 US$ of GDP) in Macedonia in 2000 to that in 2003?
Your answer should be very brief. 1.07. What is the ratio of the Amount of CO2 emissions(kg per 2005 US$ of GDP) of Middle East & North Africa (all income levels) in 2001 to that in 2002?
Your response must be concise. 1.01. What is the ratio of the Amount of CO2 emissions(kg per 2005 US$ of GDP) in Macedonia in 2001 to that in 2002?
Your response must be concise. 1.11. What is the ratio of the Amount of CO2 emissions(kg per 2005 US$ of GDP) in Middle East & North Africa (all income levels) in 2001 to that in 2003?
Provide a short and direct response. 0.99. What is the ratio of the Amount of CO2 emissions(kg per 2005 US$ of GDP) in Barbados in 2001 to that in 2003?
Offer a terse response. 0.99. What is the ratio of the Amount of CO2 emissions(kg per 2005 US$ of GDP) of Macedonia in 2001 to that in 2003?
Your response must be concise. 1.1. What is the ratio of the Amount of CO2 emissions(kg per 2005 US$ of GDP) in Middle East & North Africa (all income levels) in 2002 to that in 2003?
Make the answer very short. 0.98. What is the ratio of the Amount of CO2 emissions(kg per 2005 US$ of GDP) of Barbados in 2002 to that in 2003?
Ensure brevity in your answer.  0.99. What is the ratio of the Amount of CO2 emissions(kg per 2005 US$ of GDP) in Macedonia in 2002 to that in 2003?
Offer a very short reply. 0.99. What is the difference between the highest and the second highest Amount of CO2 emissions(kg per 2005 US$ of GDP) of Middle East & North Africa (all income levels)?
Your answer should be compact. 0.01. What is the difference between the highest and the second highest Amount of CO2 emissions(kg per 2005 US$ of GDP) of Barbados?
Keep it short and to the point. 0. What is the difference between the highest and the second highest Amount of CO2 emissions(kg per 2005 US$ of GDP) in Macedonia?
Ensure brevity in your answer.  0.25. What is the difference between the highest and the lowest Amount of CO2 emissions(kg per 2005 US$ of GDP) of Middle East & North Africa (all income levels)?
Make the answer very short. 0.14. What is the difference between the highest and the lowest Amount of CO2 emissions(kg per 2005 US$ of GDP) in Barbados?
Your answer should be very brief. 0.08. What is the difference between the highest and the lowest Amount of CO2 emissions(kg per 2005 US$ of GDP) of Macedonia?
Your answer should be very brief. 0.47. 